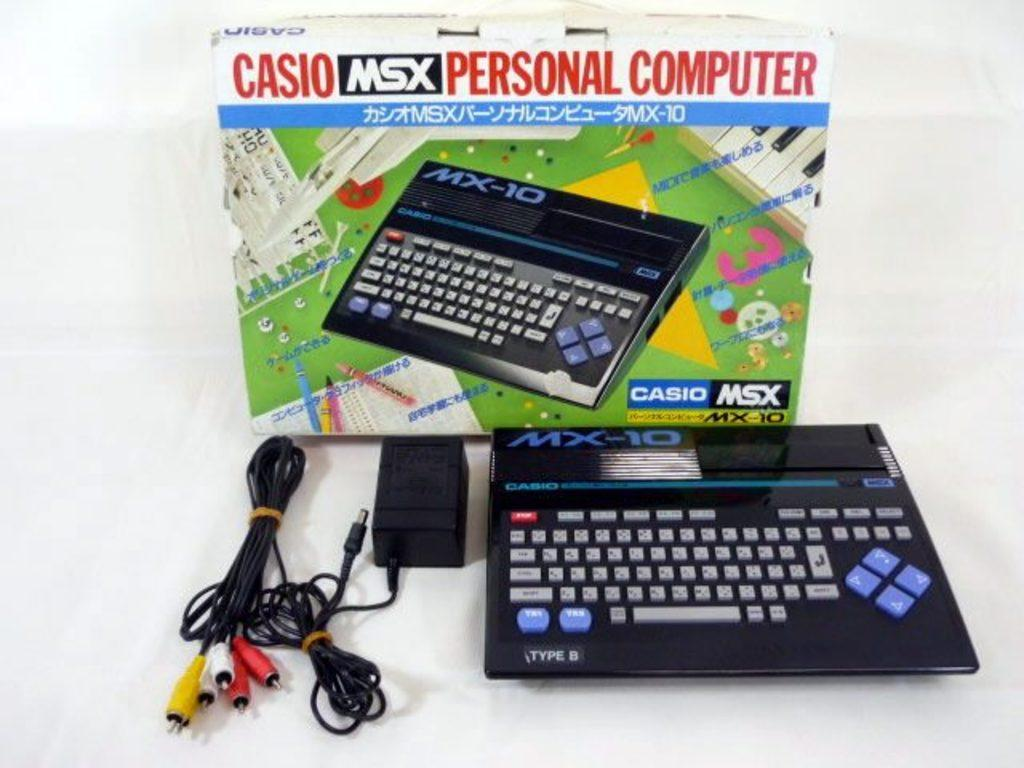Provide a one-sentence caption for the provided image. Casio msx personal computer with the charger that  goes to it. 